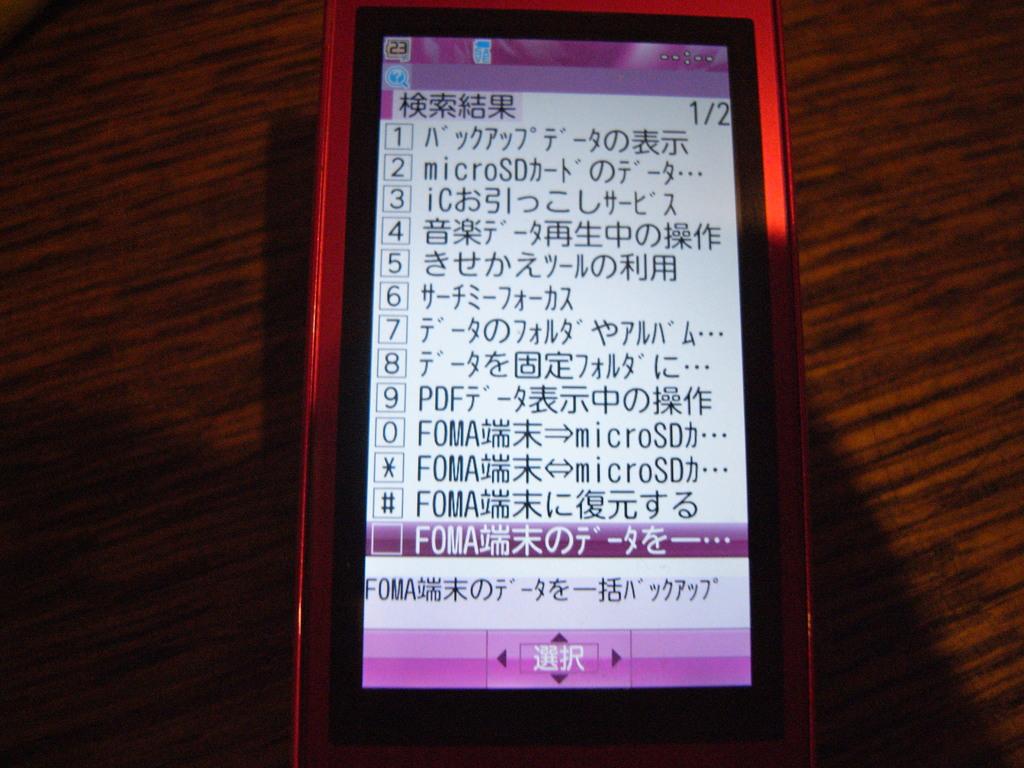What is the number in the top left corner?
Offer a very short reply. 23. What page is the phone on?
Make the answer very short. Unanswerable. 